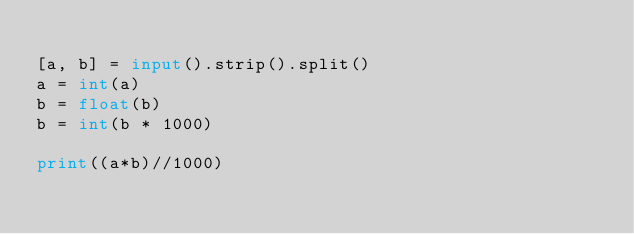Convert code to text. <code><loc_0><loc_0><loc_500><loc_500><_Python_>
[a, b] = input().strip().split()
a = int(a)
b = float(b)
b = int(b * 1000)

print((a*b)//1000)
</code> 